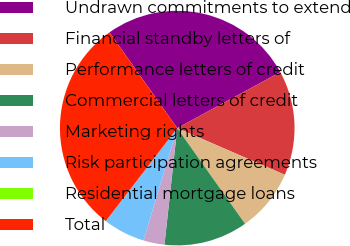Convert chart. <chart><loc_0><loc_0><loc_500><loc_500><pie_chart><fcel>Undrawn commitments to extend<fcel>Financial standby letters of<fcel>Performance letters of credit<fcel>Commercial letters of credit<fcel>Marketing rights<fcel>Risk participation agreements<fcel>Residential mortgage loans<fcel>Total<nl><fcel>26.88%<fcel>14.44%<fcel>8.67%<fcel>11.55%<fcel>2.9%<fcel>5.78%<fcel>0.01%<fcel>29.77%<nl></chart> 